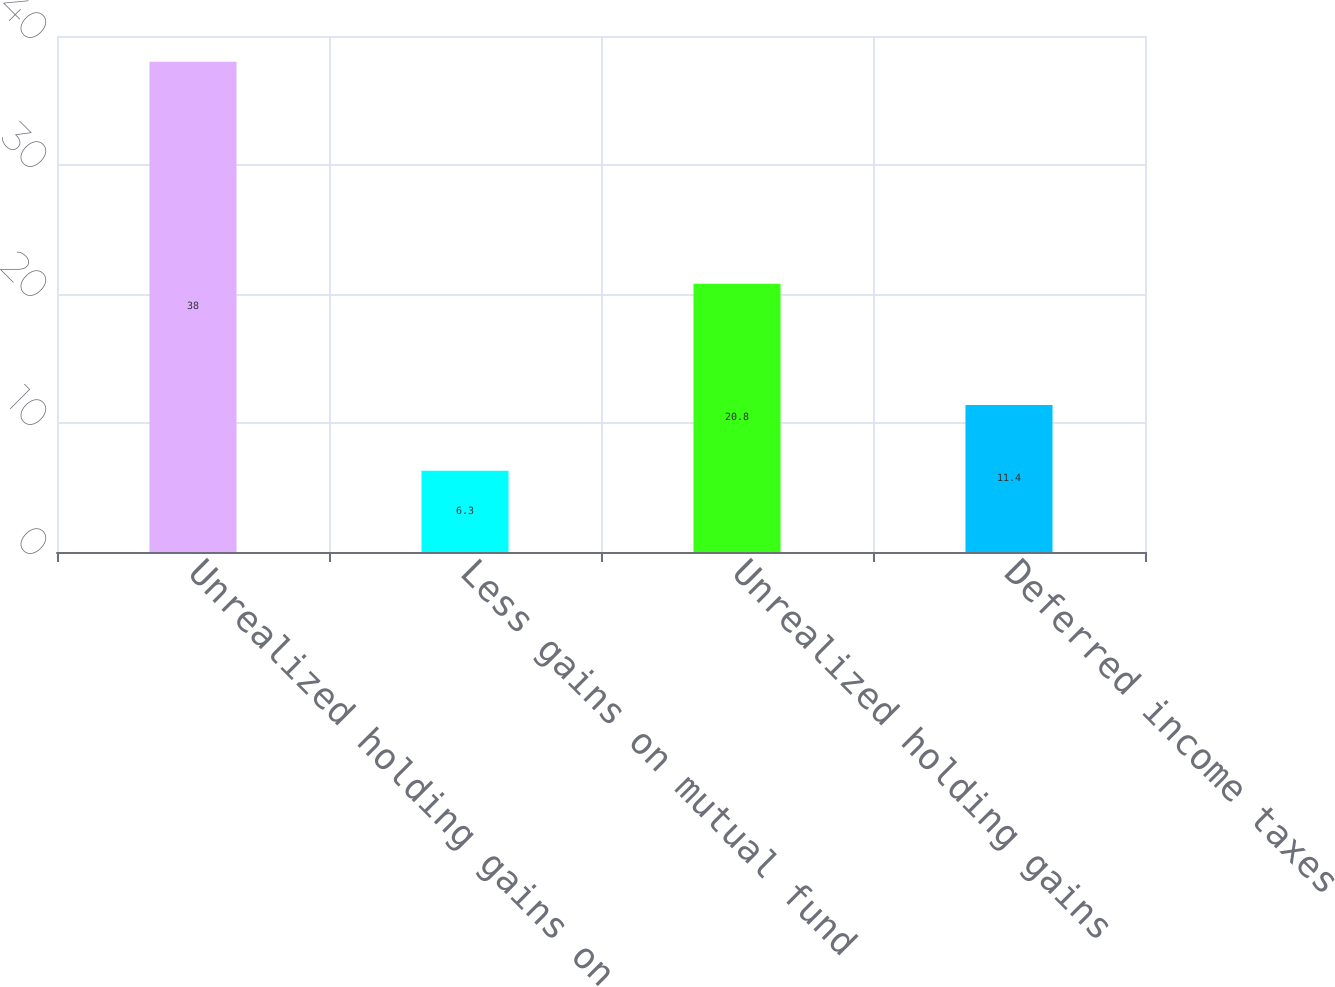Convert chart to OTSL. <chart><loc_0><loc_0><loc_500><loc_500><bar_chart><fcel>Unrealized holding gains on<fcel>Less gains on mutual fund<fcel>Unrealized holding gains<fcel>Deferred income taxes<nl><fcel>38<fcel>6.3<fcel>20.8<fcel>11.4<nl></chart> 